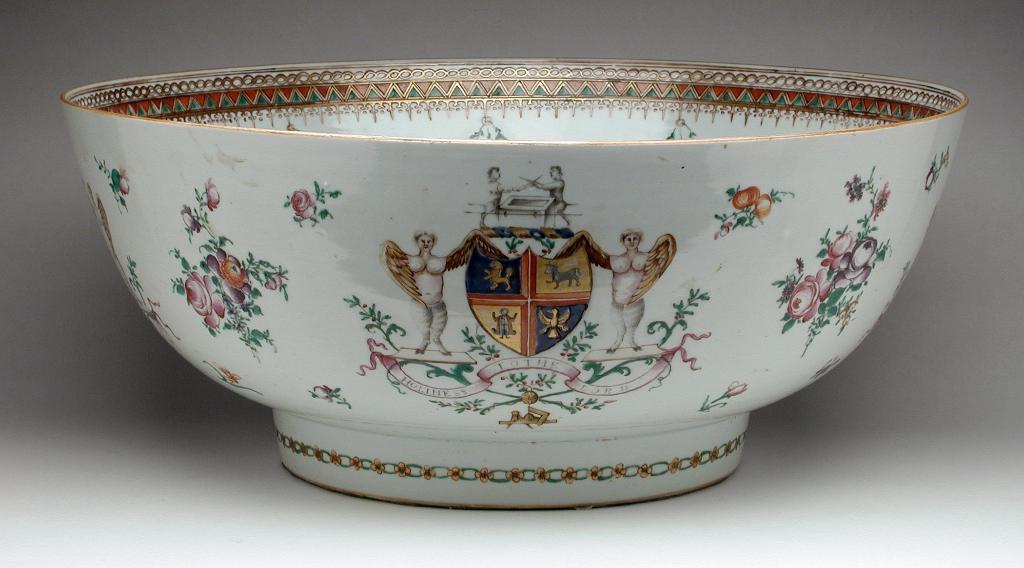What is present in the image? There is a bowl in the image. What is unique about the bowl? The bowl has a painting on it. What type of worm can be seen crawling on the throat of the person in the image? There is no person or worm present in the image; it only features a bowl with a painting on it. 